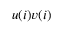Convert formula to latex. <formula><loc_0><loc_0><loc_500><loc_500>u ( i ) v ( i )</formula> 